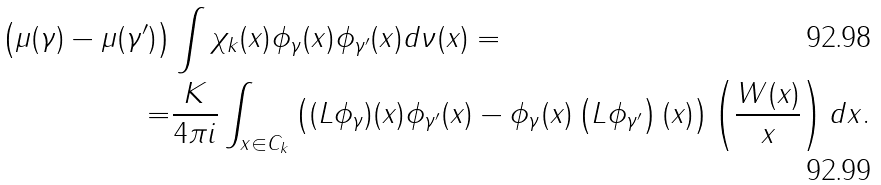Convert formula to latex. <formula><loc_0><loc_0><loc_500><loc_500>\left ( \mu ( \gamma ) - \mu ( \gamma ^ { \prime } ) \right ) & \int \chi _ { k } ( x ) \phi _ { \gamma } ( x ) \phi _ { \gamma ^ { \prime } } ( x ) d \nu ( x ) = \\ = & \frac { K } { 4 \pi i } \int _ { x \in C _ { k } } \left ( ( L \phi _ { \gamma } ) ( x ) \phi _ { \gamma ^ { \prime } } ( x ) - \phi _ { \gamma } ( x ) \left ( L \phi _ { \gamma ^ { \prime } } \right ) ( x ) \right ) \left ( \frac { W ( x ) } { x } \right ) d x .</formula> 